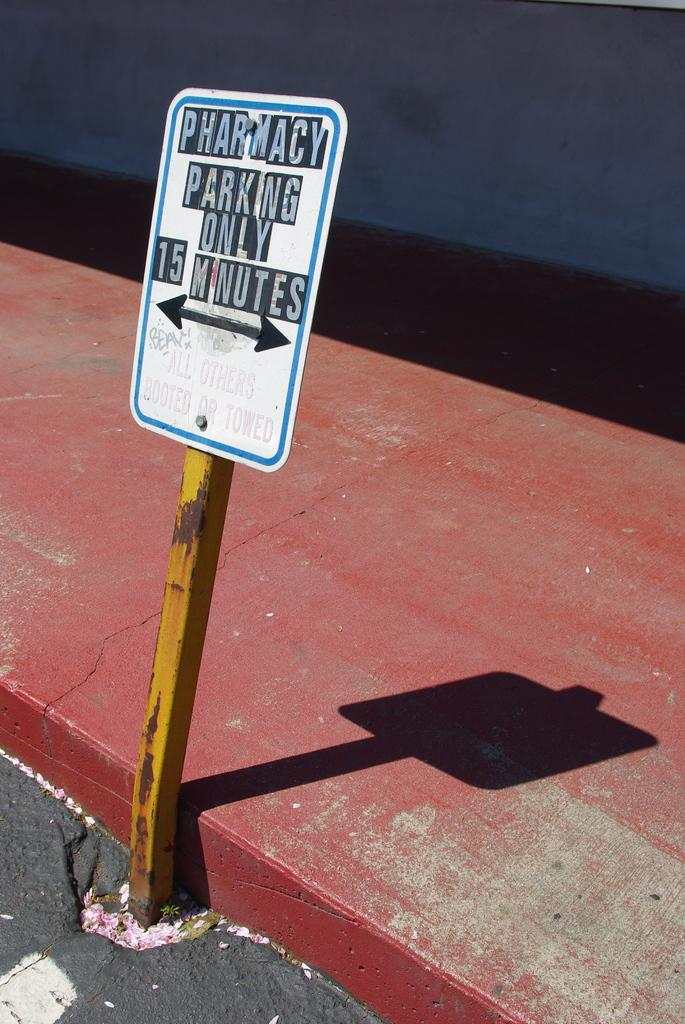Provide a one-sentence caption for the provided image. A sign designating the parking spot is only for pharmacy parking and only for fifteen minutes. 